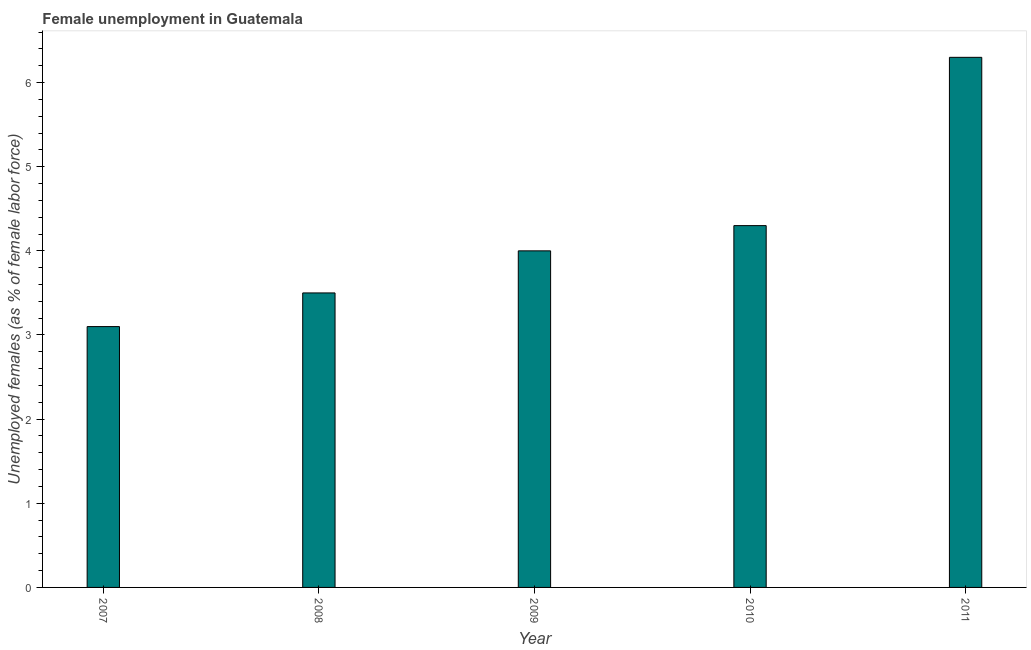Does the graph contain any zero values?
Provide a succinct answer. No. What is the title of the graph?
Make the answer very short. Female unemployment in Guatemala. What is the label or title of the Y-axis?
Your response must be concise. Unemployed females (as % of female labor force). What is the unemployed females population in 2007?
Make the answer very short. 3.1. Across all years, what is the maximum unemployed females population?
Your response must be concise. 6.3. Across all years, what is the minimum unemployed females population?
Your answer should be compact. 3.1. In which year was the unemployed females population maximum?
Provide a short and direct response. 2011. In which year was the unemployed females population minimum?
Keep it short and to the point. 2007. What is the sum of the unemployed females population?
Your answer should be compact. 21.2. What is the average unemployed females population per year?
Offer a very short reply. 4.24. What is the median unemployed females population?
Provide a short and direct response. 4. Do a majority of the years between 2011 and 2007 (inclusive) have unemployed females population greater than 0.8 %?
Ensure brevity in your answer.  Yes. What is the ratio of the unemployed females population in 2007 to that in 2009?
Offer a terse response. 0.78. In how many years, is the unemployed females population greater than the average unemployed females population taken over all years?
Your answer should be very brief. 2. How many bars are there?
Provide a short and direct response. 5. What is the difference between two consecutive major ticks on the Y-axis?
Ensure brevity in your answer.  1. Are the values on the major ticks of Y-axis written in scientific E-notation?
Offer a terse response. No. What is the Unemployed females (as % of female labor force) of 2007?
Your response must be concise. 3.1. What is the Unemployed females (as % of female labor force) in 2009?
Your response must be concise. 4. What is the Unemployed females (as % of female labor force) in 2010?
Keep it short and to the point. 4.3. What is the Unemployed females (as % of female labor force) in 2011?
Offer a very short reply. 6.3. What is the difference between the Unemployed females (as % of female labor force) in 2007 and 2011?
Your response must be concise. -3.2. What is the difference between the Unemployed females (as % of female labor force) in 2008 and 2011?
Your answer should be very brief. -2.8. What is the difference between the Unemployed females (as % of female labor force) in 2009 and 2010?
Your answer should be compact. -0.3. What is the difference between the Unemployed females (as % of female labor force) in 2009 and 2011?
Provide a succinct answer. -2.3. What is the difference between the Unemployed females (as % of female labor force) in 2010 and 2011?
Provide a short and direct response. -2. What is the ratio of the Unemployed females (as % of female labor force) in 2007 to that in 2008?
Your response must be concise. 0.89. What is the ratio of the Unemployed females (as % of female labor force) in 2007 to that in 2009?
Make the answer very short. 0.78. What is the ratio of the Unemployed females (as % of female labor force) in 2007 to that in 2010?
Ensure brevity in your answer.  0.72. What is the ratio of the Unemployed females (as % of female labor force) in 2007 to that in 2011?
Make the answer very short. 0.49. What is the ratio of the Unemployed females (as % of female labor force) in 2008 to that in 2010?
Provide a short and direct response. 0.81. What is the ratio of the Unemployed females (as % of female labor force) in 2008 to that in 2011?
Provide a succinct answer. 0.56. What is the ratio of the Unemployed females (as % of female labor force) in 2009 to that in 2011?
Your response must be concise. 0.64. What is the ratio of the Unemployed females (as % of female labor force) in 2010 to that in 2011?
Your answer should be compact. 0.68. 